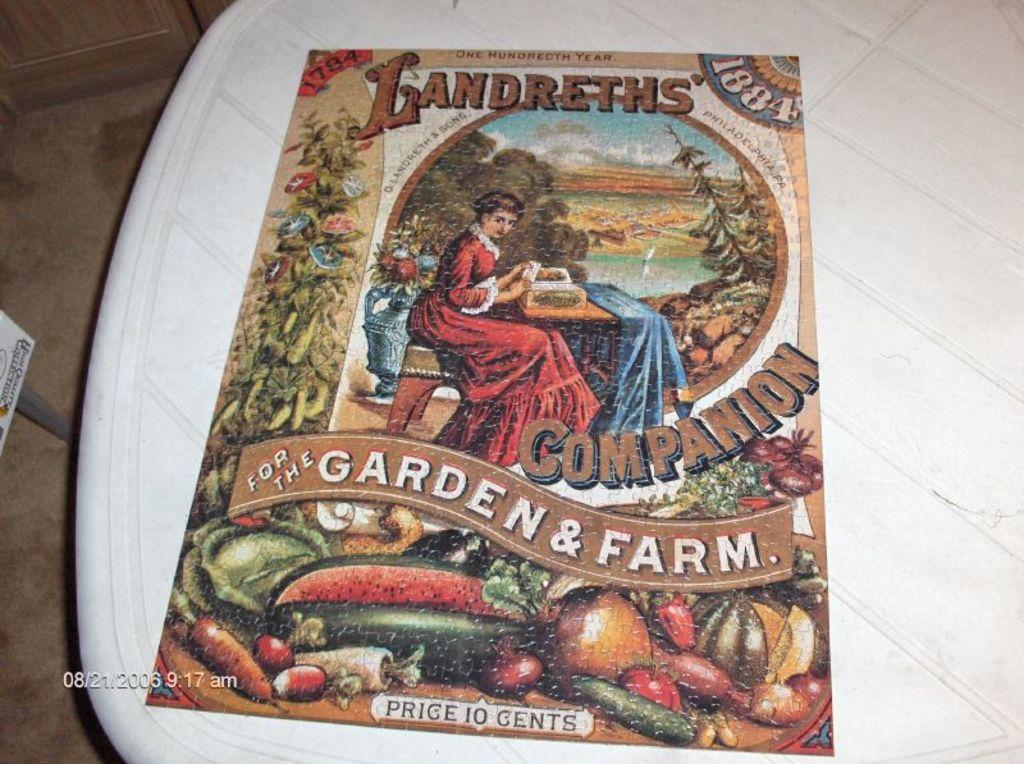<image>
Render a clear and concise summary of the photo. A puzzle displayed on a table has a picture of a woman and the words Landreths Companion for the Garden and Farm. 